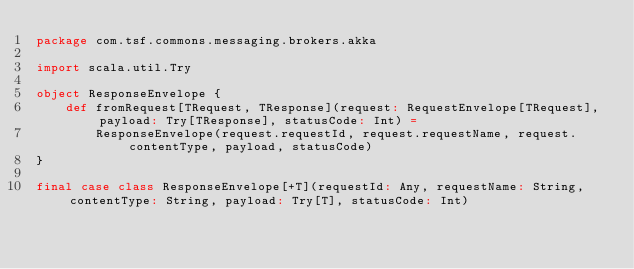Convert code to text. <code><loc_0><loc_0><loc_500><loc_500><_Scala_>package com.tsf.commons.messaging.brokers.akka

import scala.util.Try

object ResponseEnvelope {
	def fromRequest[TRequest, TResponse](request: RequestEnvelope[TRequest], payload: Try[TResponse], statusCode: Int) =
		ResponseEnvelope(request.requestId, request.requestName, request.contentType, payload, statusCode)
}

final case class ResponseEnvelope[+T](requestId: Any, requestName: String, contentType: String, payload: Try[T], statusCode: Int)</code> 